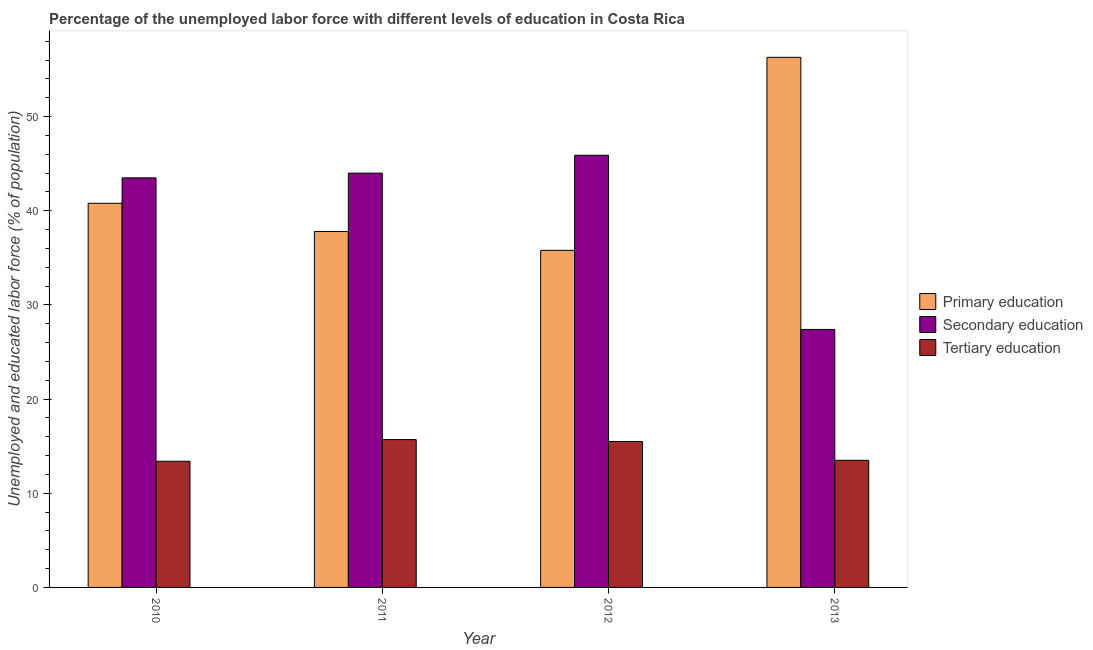How many different coloured bars are there?
Give a very brief answer. 3. How many groups of bars are there?
Provide a succinct answer. 4. Are the number of bars on each tick of the X-axis equal?
Ensure brevity in your answer.  Yes. How many bars are there on the 3rd tick from the left?
Give a very brief answer. 3. What is the label of the 3rd group of bars from the left?
Offer a terse response. 2012. In how many cases, is the number of bars for a given year not equal to the number of legend labels?
Your answer should be very brief. 0. What is the percentage of labor force who received secondary education in 2010?
Your answer should be very brief. 43.5. Across all years, what is the maximum percentage of labor force who received secondary education?
Your answer should be very brief. 45.9. Across all years, what is the minimum percentage of labor force who received tertiary education?
Your answer should be compact. 13.4. In which year was the percentage of labor force who received secondary education minimum?
Give a very brief answer. 2013. What is the total percentage of labor force who received primary education in the graph?
Offer a terse response. 170.7. What is the difference between the percentage of labor force who received tertiary education in 2010 and that in 2013?
Make the answer very short. -0.1. What is the difference between the percentage of labor force who received secondary education in 2010 and the percentage of labor force who received tertiary education in 2011?
Offer a terse response. -0.5. What is the average percentage of labor force who received primary education per year?
Offer a terse response. 42.67. In how many years, is the percentage of labor force who received tertiary education greater than 6 %?
Offer a very short reply. 4. What is the ratio of the percentage of labor force who received tertiary education in 2011 to that in 2012?
Make the answer very short. 1.01. Is the difference between the percentage of labor force who received primary education in 2010 and 2012 greater than the difference between the percentage of labor force who received tertiary education in 2010 and 2012?
Give a very brief answer. No. What is the difference between the highest and the second highest percentage of labor force who received secondary education?
Your answer should be very brief. 1.9. What is the difference between the highest and the lowest percentage of labor force who received secondary education?
Your answer should be compact. 18.5. In how many years, is the percentage of labor force who received tertiary education greater than the average percentage of labor force who received tertiary education taken over all years?
Provide a succinct answer. 2. Is the sum of the percentage of labor force who received primary education in 2010 and 2011 greater than the maximum percentage of labor force who received secondary education across all years?
Provide a short and direct response. Yes. What does the 2nd bar from the left in 2013 represents?
Ensure brevity in your answer.  Secondary education. What does the 2nd bar from the right in 2012 represents?
Your answer should be compact. Secondary education. Is it the case that in every year, the sum of the percentage of labor force who received primary education and percentage of labor force who received secondary education is greater than the percentage of labor force who received tertiary education?
Keep it short and to the point. Yes. Are the values on the major ticks of Y-axis written in scientific E-notation?
Offer a very short reply. No. Where does the legend appear in the graph?
Offer a very short reply. Center right. How many legend labels are there?
Give a very brief answer. 3. What is the title of the graph?
Your answer should be very brief. Percentage of the unemployed labor force with different levels of education in Costa Rica. What is the label or title of the Y-axis?
Make the answer very short. Unemployed and educated labor force (% of population). What is the Unemployed and educated labor force (% of population) in Primary education in 2010?
Provide a succinct answer. 40.8. What is the Unemployed and educated labor force (% of population) in Secondary education in 2010?
Give a very brief answer. 43.5. What is the Unemployed and educated labor force (% of population) of Tertiary education in 2010?
Give a very brief answer. 13.4. What is the Unemployed and educated labor force (% of population) in Primary education in 2011?
Offer a very short reply. 37.8. What is the Unemployed and educated labor force (% of population) in Tertiary education in 2011?
Keep it short and to the point. 15.7. What is the Unemployed and educated labor force (% of population) in Primary education in 2012?
Your answer should be very brief. 35.8. What is the Unemployed and educated labor force (% of population) of Secondary education in 2012?
Keep it short and to the point. 45.9. What is the Unemployed and educated labor force (% of population) in Tertiary education in 2012?
Provide a short and direct response. 15.5. What is the Unemployed and educated labor force (% of population) of Primary education in 2013?
Provide a short and direct response. 56.3. What is the Unemployed and educated labor force (% of population) in Secondary education in 2013?
Offer a very short reply. 27.4. Across all years, what is the maximum Unemployed and educated labor force (% of population) of Primary education?
Provide a short and direct response. 56.3. Across all years, what is the maximum Unemployed and educated labor force (% of population) of Secondary education?
Your answer should be compact. 45.9. Across all years, what is the maximum Unemployed and educated labor force (% of population) in Tertiary education?
Offer a terse response. 15.7. Across all years, what is the minimum Unemployed and educated labor force (% of population) in Primary education?
Your response must be concise. 35.8. Across all years, what is the minimum Unemployed and educated labor force (% of population) of Secondary education?
Provide a short and direct response. 27.4. Across all years, what is the minimum Unemployed and educated labor force (% of population) in Tertiary education?
Your answer should be very brief. 13.4. What is the total Unemployed and educated labor force (% of population) of Primary education in the graph?
Give a very brief answer. 170.7. What is the total Unemployed and educated labor force (% of population) of Secondary education in the graph?
Make the answer very short. 160.8. What is the total Unemployed and educated labor force (% of population) in Tertiary education in the graph?
Make the answer very short. 58.1. What is the difference between the Unemployed and educated labor force (% of population) of Secondary education in 2010 and that in 2011?
Offer a very short reply. -0.5. What is the difference between the Unemployed and educated labor force (% of population) in Tertiary education in 2010 and that in 2011?
Your response must be concise. -2.3. What is the difference between the Unemployed and educated labor force (% of population) of Primary education in 2010 and that in 2012?
Keep it short and to the point. 5. What is the difference between the Unemployed and educated labor force (% of population) in Tertiary education in 2010 and that in 2012?
Offer a very short reply. -2.1. What is the difference between the Unemployed and educated labor force (% of population) in Primary education in 2010 and that in 2013?
Keep it short and to the point. -15.5. What is the difference between the Unemployed and educated labor force (% of population) of Primary education in 2011 and that in 2012?
Provide a succinct answer. 2. What is the difference between the Unemployed and educated labor force (% of population) of Tertiary education in 2011 and that in 2012?
Keep it short and to the point. 0.2. What is the difference between the Unemployed and educated labor force (% of population) of Primary education in 2011 and that in 2013?
Ensure brevity in your answer.  -18.5. What is the difference between the Unemployed and educated labor force (% of population) in Secondary education in 2011 and that in 2013?
Provide a succinct answer. 16.6. What is the difference between the Unemployed and educated labor force (% of population) in Primary education in 2012 and that in 2013?
Ensure brevity in your answer.  -20.5. What is the difference between the Unemployed and educated labor force (% of population) of Tertiary education in 2012 and that in 2013?
Your answer should be very brief. 2. What is the difference between the Unemployed and educated labor force (% of population) in Primary education in 2010 and the Unemployed and educated labor force (% of population) in Tertiary education in 2011?
Give a very brief answer. 25.1. What is the difference between the Unemployed and educated labor force (% of population) of Secondary education in 2010 and the Unemployed and educated labor force (% of population) of Tertiary education in 2011?
Your response must be concise. 27.8. What is the difference between the Unemployed and educated labor force (% of population) of Primary education in 2010 and the Unemployed and educated labor force (% of population) of Tertiary education in 2012?
Offer a very short reply. 25.3. What is the difference between the Unemployed and educated labor force (% of population) of Secondary education in 2010 and the Unemployed and educated labor force (% of population) of Tertiary education in 2012?
Your answer should be compact. 28. What is the difference between the Unemployed and educated labor force (% of population) of Primary education in 2010 and the Unemployed and educated labor force (% of population) of Tertiary education in 2013?
Offer a very short reply. 27.3. What is the difference between the Unemployed and educated labor force (% of population) of Primary education in 2011 and the Unemployed and educated labor force (% of population) of Tertiary education in 2012?
Provide a succinct answer. 22.3. What is the difference between the Unemployed and educated labor force (% of population) of Primary education in 2011 and the Unemployed and educated labor force (% of population) of Secondary education in 2013?
Your response must be concise. 10.4. What is the difference between the Unemployed and educated labor force (% of population) in Primary education in 2011 and the Unemployed and educated labor force (% of population) in Tertiary education in 2013?
Your response must be concise. 24.3. What is the difference between the Unemployed and educated labor force (% of population) of Secondary education in 2011 and the Unemployed and educated labor force (% of population) of Tertiary education in 2013?
Give a very brief answer. 30.5. What is the difference between the Unemployed and educated labor force (% of population) in Primary education in 2012 and the Unemployed and educated labor force (% of population) in Tertiary education in 2013?
Ensure brevity in your answer.  22.3. What is the difference between the Unemployed and educated labor force (% of population) in Secondary education in 2012 and the Unemployed and educated labor force (% of population) in Tertiary education in 2013?
Give a very brief answer. 32.4. What is the average Unemployed and educated labor force (% of population) in Primary education per year?
Your answer should be very brief. 42.67. What is the average Unemployed and educated labor force (% of population) in Secondary education per year?
Make the answer very short. 40.2. What is the average Unemployed and educated labor force (% of population) of Tertiary education per year?
Your response must be concise. 14.53. In the year 2010, what is the difference between the Unemployed and educated labor force (% of population) in Primary education and Unemployed and educated labor force (% of population) in Tertiary education?
Your answer should be compact. 27.4. In the year 2010, what is the difference between the Unemployed and educated labor force (% of population) in Secondary education and Unemployed and educated labor force (% of population) in Tertiary education?
Make the answer very short. 30.1. In the year 2011, what is the difference between the Unemployed and educated labor force (% of population) of Primary education and Unemployed and educated labor force (% of population) of Tertiary education?
Your answer should be compact. 22.1. In the year 2011, what is the difference between the Unemployed and educated labor force (% of population) in Secondary education and Unemployed and educated labor force (% of population) in Tertiary education?
Make the answer very short. 28.3. In the year 2012, what is the difference between the Unemployed and educated labor force (% of population) in Primary education and Unemployed and educated labor force (% of population) in Secondary education?
Keep it short and to the point. -10.1. In the year 2012, what is the difference between the Unemployed and educated labor force (% of population) in Primary education and Unemployed and educated labor force (% of population) in Tertiary education?
Your answer should be very brief. 20.3. In the year 2012, what is the difference between the Unemployed and educated labor force (% of population) in Secondary education and Unemployed and educated labor force (% of population) in Tertiary education?
Keep it short and to the point. 30.4. In the year 2013, what is the difference between the Unemployed and educated labor force (% of population) in Primary education and Unemployed and educated labor force (% of population) in Secondary education?
Ensure brevity in your answer.  28.9. In the year 2013, what is the difference between the Unemployed and educated labor force (% of population) of Primary education and Unemployed and educated labor force (% of population) of Tertiary education?
Make the answer very short. 42.8. In the year 2013, what is the difference between the Unemployed and educated labor force (% of population) in Secondary education and Unemployed and educated labor force (% of population) in Tertiary education?
Your response must be concise. 13.9. What is the ratio of the Unemployed and educated labor force (% of population) of Primary education in 2010 to that in 2011?
Provide a succinct answer. 1.08. What is the ratio of the Unemployed and educated labor force (% of population) in Tertiary education in 2010 to that in 2011?
Keep it short and to the point. 0.85. What is the ratio of the Unemployed and educated labor force (% of population) of Primary education in 2010 to that in 2012?
Offer a terse response. 1.14. What is the ratio of the Unemployed and educated labor force (% of population) of Secondary education in 2010 to that in 2012?
Your response must be concise. 0.95. What is the ratio of the Unemployed and educated labor force (% of population) in Tertiary education in 2010 to that in 2012?
Make the answer very short. 0.86. What is the ratio of the Unemployed and educated labor force (% of population) in Primary education in 2010 to that in 2013?
Provide a short and direct response. 0.72. What is the ratio of the Unemployed and educated labor force (% of population) of Secondary education in 2010 to that in 2013?
Provide a short and direct response. 1.59. What is the ratio of the Unemployed and educated labor force (% of population) in Primary education in 2011 to that in 2012?
Your response must be concise. 1.06. What is the ratio of the Unemployed and educated labor force (% of population) of Secondary education in 2011 to that in 2012?
Give a very brief answer. 0.96. What is the ratio of the Unemployed and educated labor force (% of population) of Tertiary education in 2011 to that in 2012?
Your answer should be very brief. 1.01. What is the ratio of the Unemployed and educated labor force (% of population) in Primary education in 2011 to that in 2013?
Ensure brevity in your answer.  0.67. What is the ratio of the Unemployed and educated labor force (% of population) of Secondary education in 2011 to that in 2013?
Make the answer very short. 1.61. What is the ratio of the Unemployed and educated labor force (% of population) of Tertiary education in 2011 to that in 2013?
Offer a terse response. 1.16. What is the ratio of the Unemployed and educated labor force (% of population) of Primary education in 2012 to that in 2013?
Offer a terse response. 0.64. What is the ratio of the Unemployed and educated labor force (% of population) in Secondary education in 2012 to that in 2013?
Offer a very short reply. 1.68. What is the ratio of the Unemployed and educated labor force (% of population) in Tertiary education in 2012 to that in 2013?
Provide a succinct answer. 1.15. What is the difference between the highest and the second highest Unemployed and educated labor force (% of population) in Primary education?
Offer a very short reply. 15.5. What is the difference between the highest and the second highest Unemployed and educated labor force (% of population) of Tertiary education?
Provide a short and direct response. 0.2. What is the difference between the highest and the lowest Unemployed and educated labor force (% of population) in Primary education?
Provide a short and direct response. 20.5. What is the difference between the highest and the lowest Unemployed and educated labor force (% of population) in Secondary education?
Make the answer very short. 18.5. What is the difference between the highest and the lowest Unemployed and educated labor force (% of population) in Tertiary education?
Ensure brevity in your answer.  2.3. 